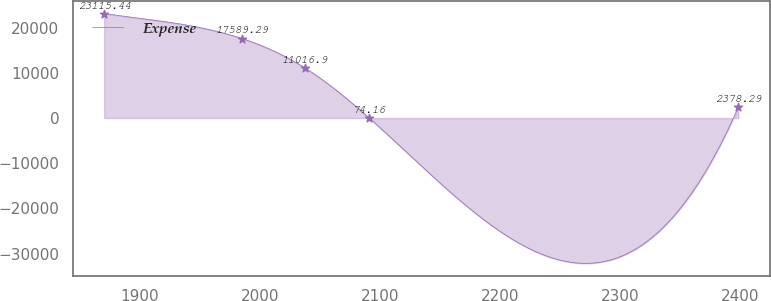Convert chart to OTSL. <chart><loc_0><loc_0><loc_500><loc_500><line_chart><ecel><fcel>Expense<nl><fcel>1870.38<fcel>23115.4<nl><fcel>1985.24<fcel>17589.3<nl><fcel>2038.07<fcel>11016.9<nl><fcel>2090.9<fcel>74.16<nl><fcel>2398.71<fcel>2378.29<nl></chart> 